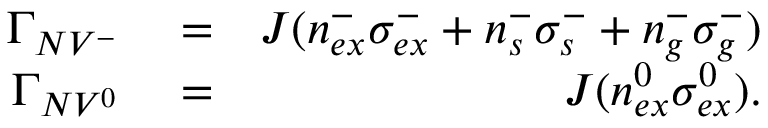Convert formula to latex. <formula><loc_0><loc_0><loc_500><loc_500>\begin{array} { r l r } { \Gamma _ { N V ^ { - } } } & = } & { J ( n _ { e x } ^ { - } \sigma _ { e x } ^ { - } + n _ { s } ^ { - } \sigma _ { s } ^ { - } + n _ { g } ^ { - } \sigma _ { g } ^ { - } ) } \\ { \Gamma _ { N V ^ { 0 } } } & = } & { J ( n _ { e x } ^ { 0 } \sigma _ { e x } ^ { 0 } ) . } \end{array}</formula> 